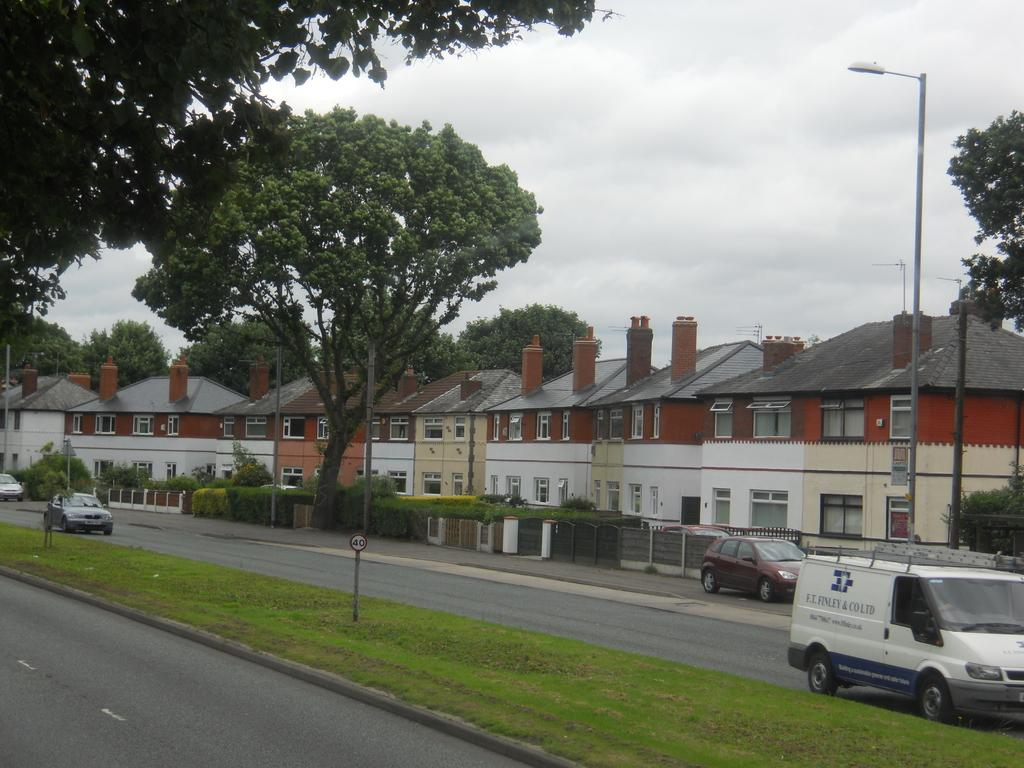What type of structures can be seen in the image? There are buildings in the image. What other natural elements are present in the image? There are trees in the image. What is happening on the road in the image? Cars and a van are moving on the road in the image. What type of lighting is present in the image? There is a pole light in the image. How would you describe the weather based on the image? The sky is cloudy in the image. What type of breakfast is being served in the image? There is no breakfast present in the image. What sound do the bells make in the image? There are no bells present in the image. 